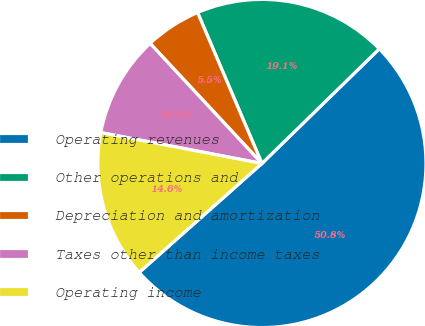Convert chart to OTSL. <chart><loc_0><loc_0><loc_500><loc_500><pie_chart><fcel>Operating revenues<fcel>Other operations and<fcel>Depreciation and amortization<fcel>Taxes other than income taxes<fcel>Operating income<nl><fcel>50.76%<fcel>19.1%<fcel>5.52%<fcel>10.05%<fcel>14.57%<nl></chart> 